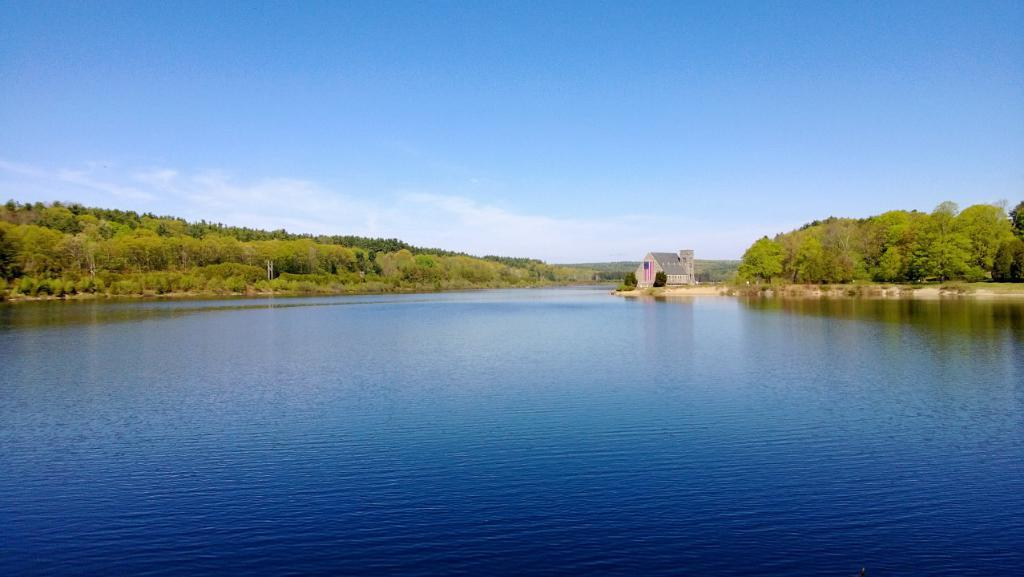What is the main feature at the center of the image? There is a river at the center of the image. What can be seen in the background of the image? There are trees, buildings, and the sky visible in the background of the image. How does the boy use his mouth to interact with the river in the image? There is no boy present in the image, and therefore no interaction with the river can be observed. 